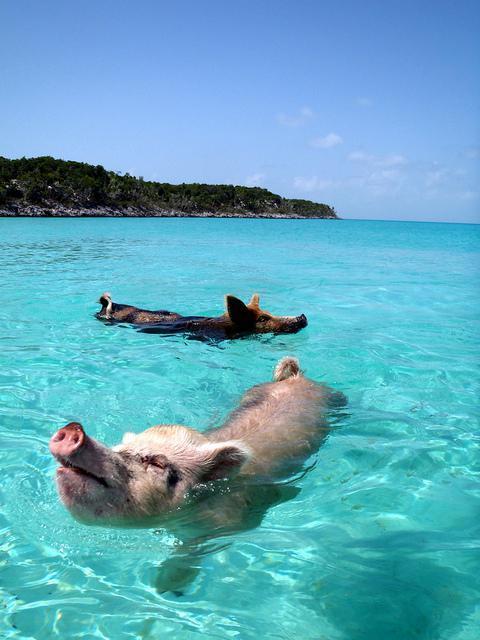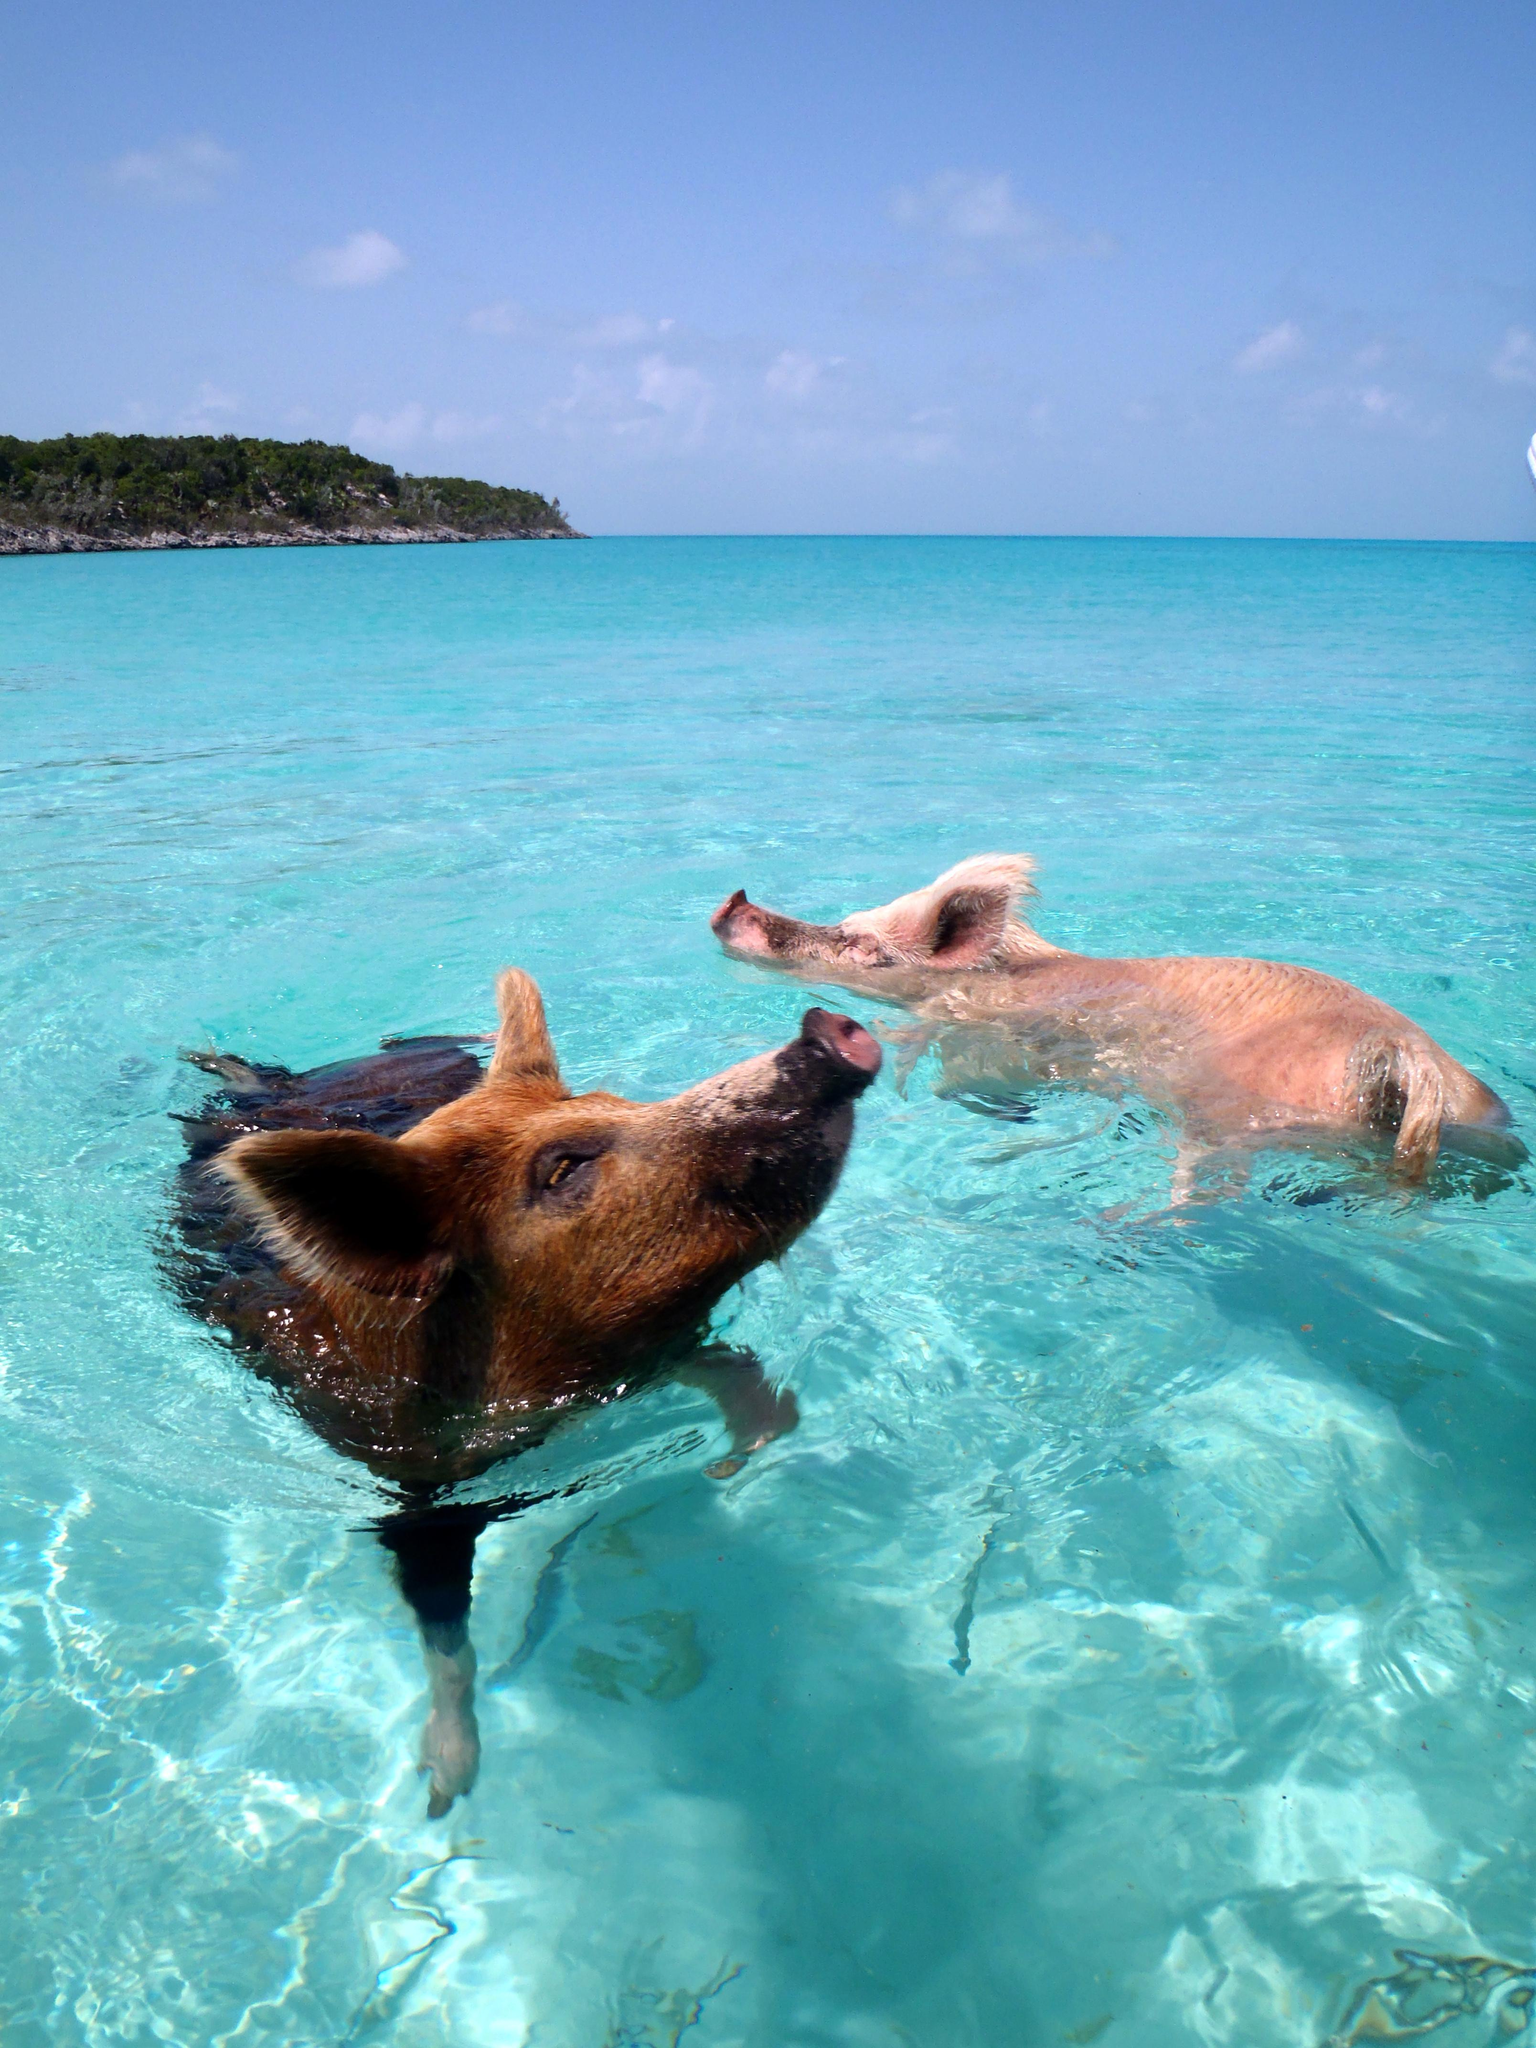The first image is the image on the left, the second image is the image on the right. Assess this claim about the two images: "Each image shows two pigs swimming in a body of water, and in at least one image, the pigs' snouts face opposite directions.". Correct or not? Answer yes or no. Yes. The first image is the image on the left, the second image is the image on the right. Given the left and right images, does the statement "There are exactly four pigs swimming." hold true? Answer yes or no. Yes. 